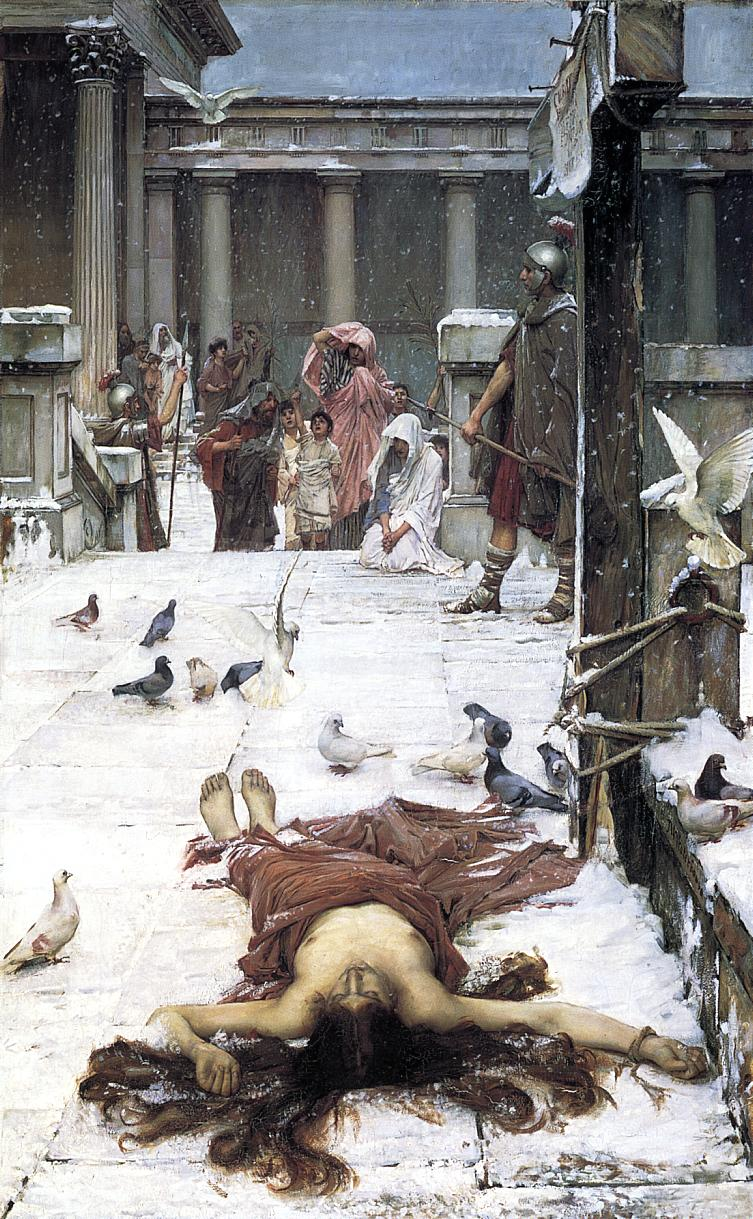Can you describe the emotions portrayed by the characters surrounding the fallen woman? The characters display a spectrum of emotions that add depth to the painting. The guards show a stoic demeanor, reflective of their role and the discipline it entails. The women and children exhibit concern and sorrow, their faces turned towards the fallen figure with expressions of pity and fear. This blend of reactions contributes to a dramatic and emotional atmosphere, framing the central event as a moment of significant communal impact. 